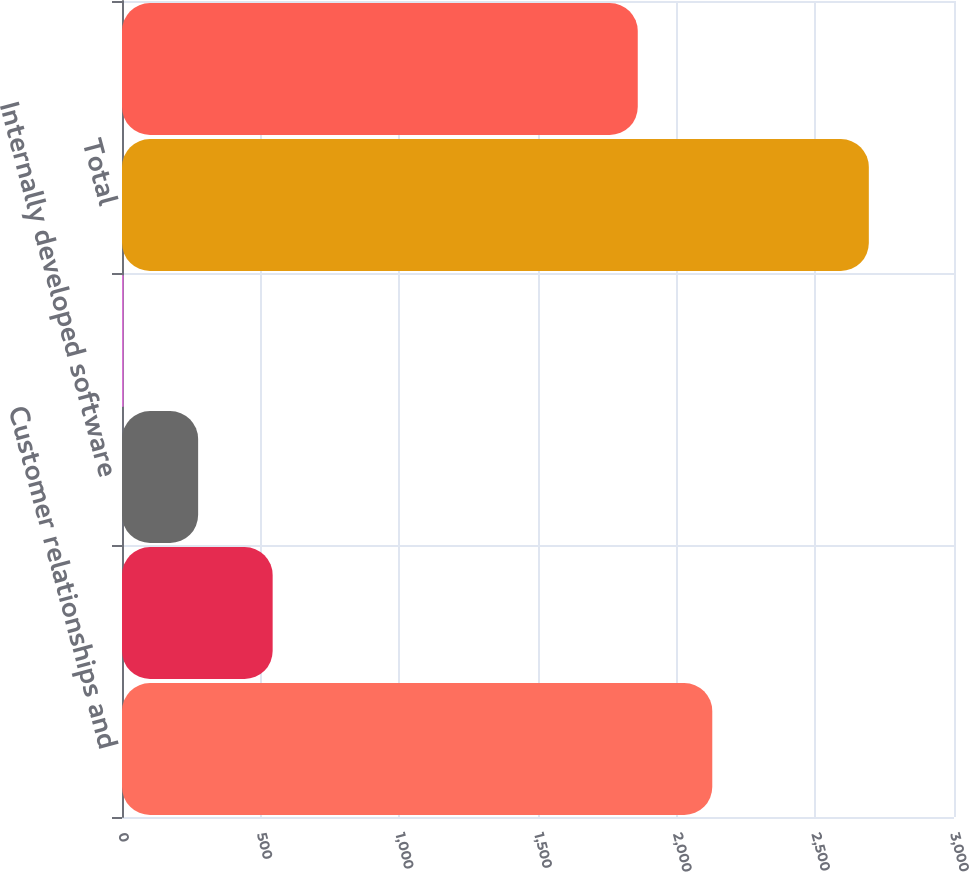Convert chart to OTSL. <chart><loc_0><loc_0><loc_500><loc_500><bar_chart><fcel>Customer relationships and<fcel>Trade name<fcel>Internally developed software<fcel>Other<fcel>Total<fcel>Customer relationships<nl><fcel>2128.41<fcel>543.22<fcel>274.51<fcel>5.8<fcel>2692.9<fcel>1859.7<nl></chart> 